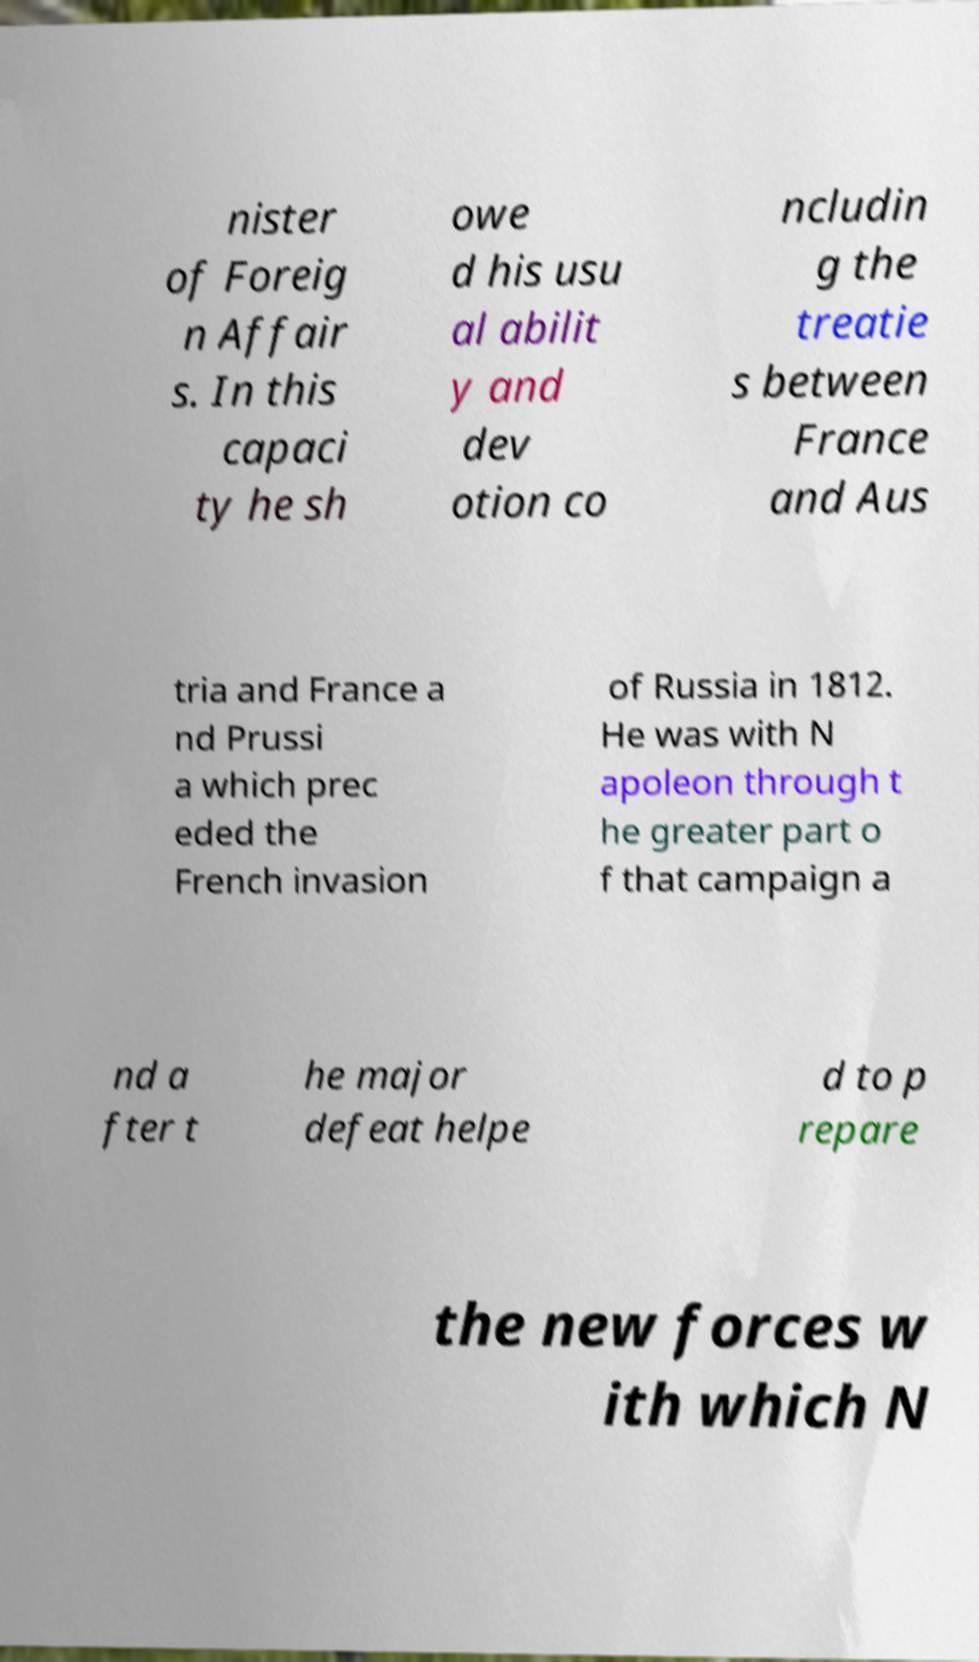Please read and relay the text visible in this image. What does it say? nister of Foreig n Affair s. In this capaci ty he sh owe d his usu al abilit y and dev otion co ncludin g the treatie s between France and Aus tria and France a nd Prussi a which prec eded the French invasion of Russia in 1812. He was with N apoleon through t he greater part o f that campaign a nd a fter t he major defeat helpe d to p repare the new forces w ith which N 